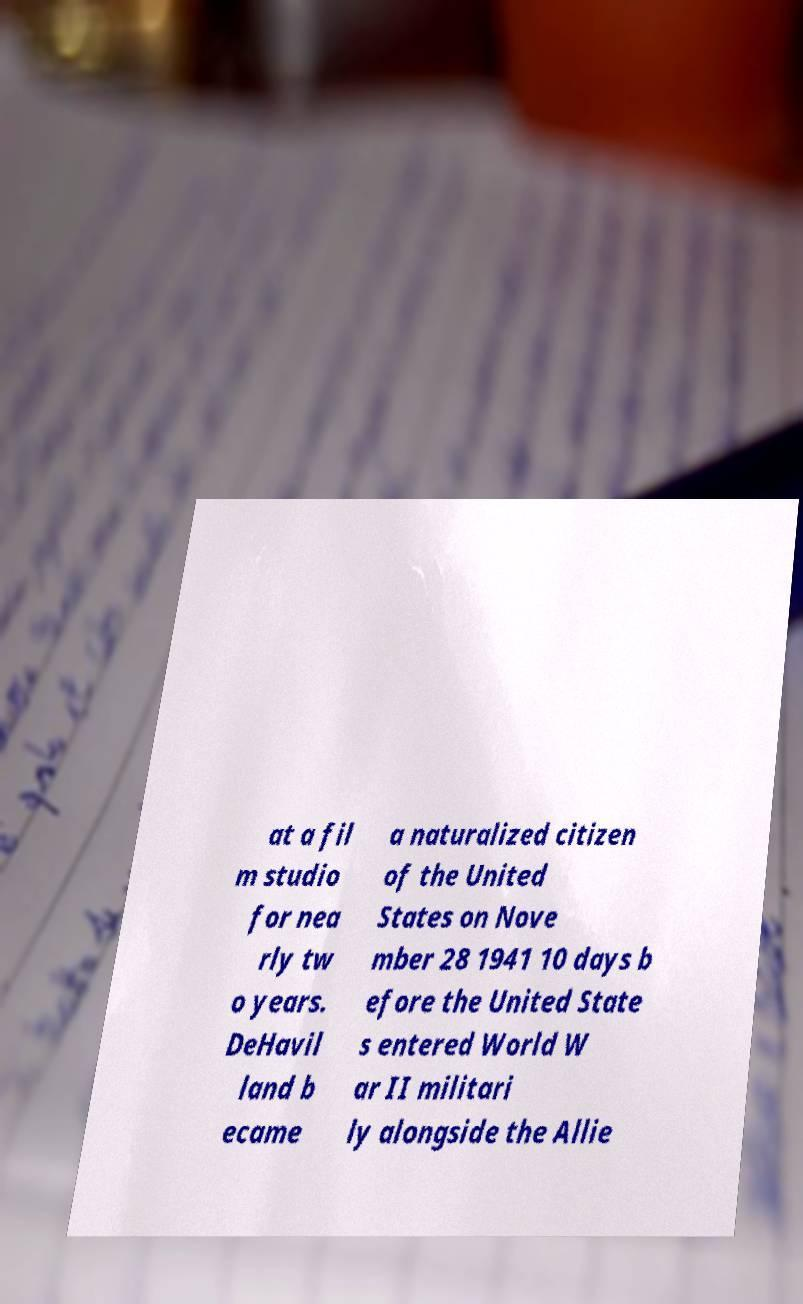Please identify and transcribe the text found in this image. at a fil m studio for nea rly tw o years. DeHavil land b ecame a naturalized citizen of the United States on Nove mber 28 1941 10 days b efore the United State s entered World W ar II militari ly alongside the Allie 